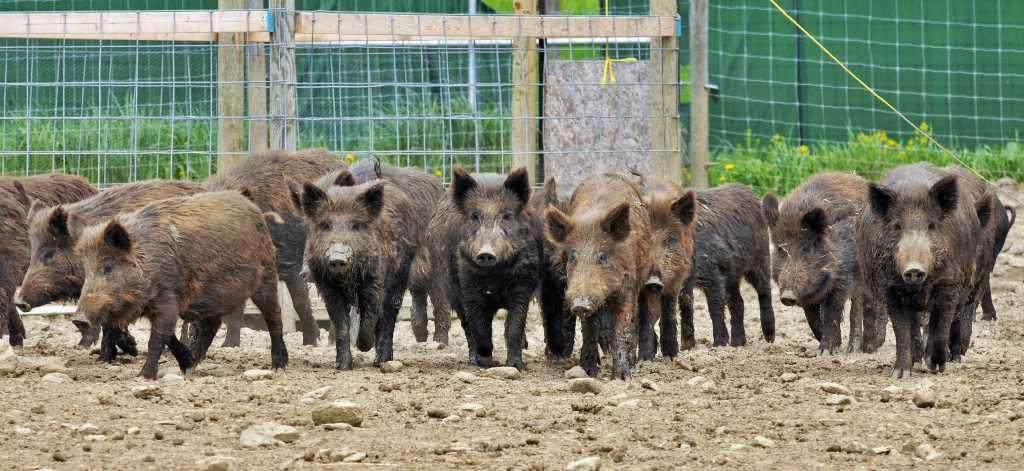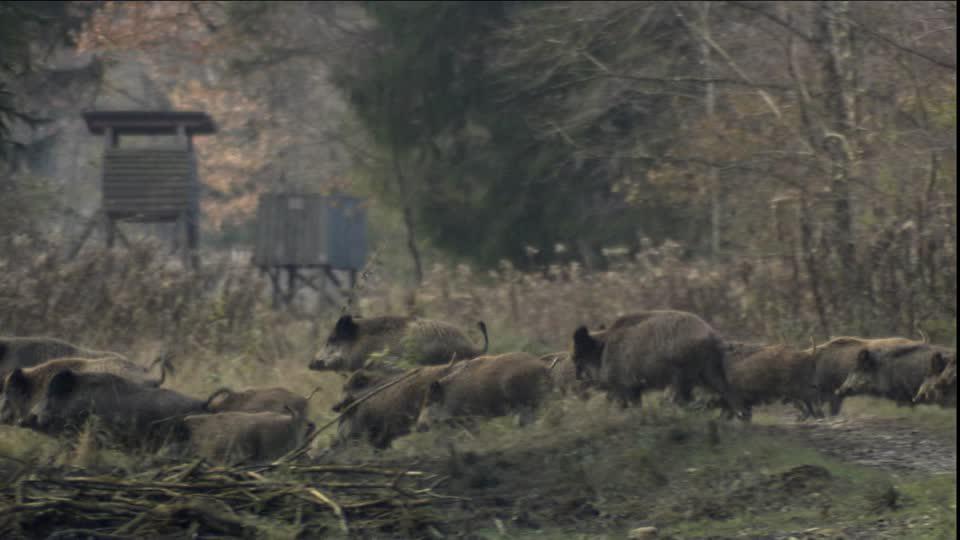The first image is the image on the left, the second image is the image on the right. Assess this claim about the two images: "Contains one picture with three or less pigs.". Correct or not? Answer yes or no. No. 